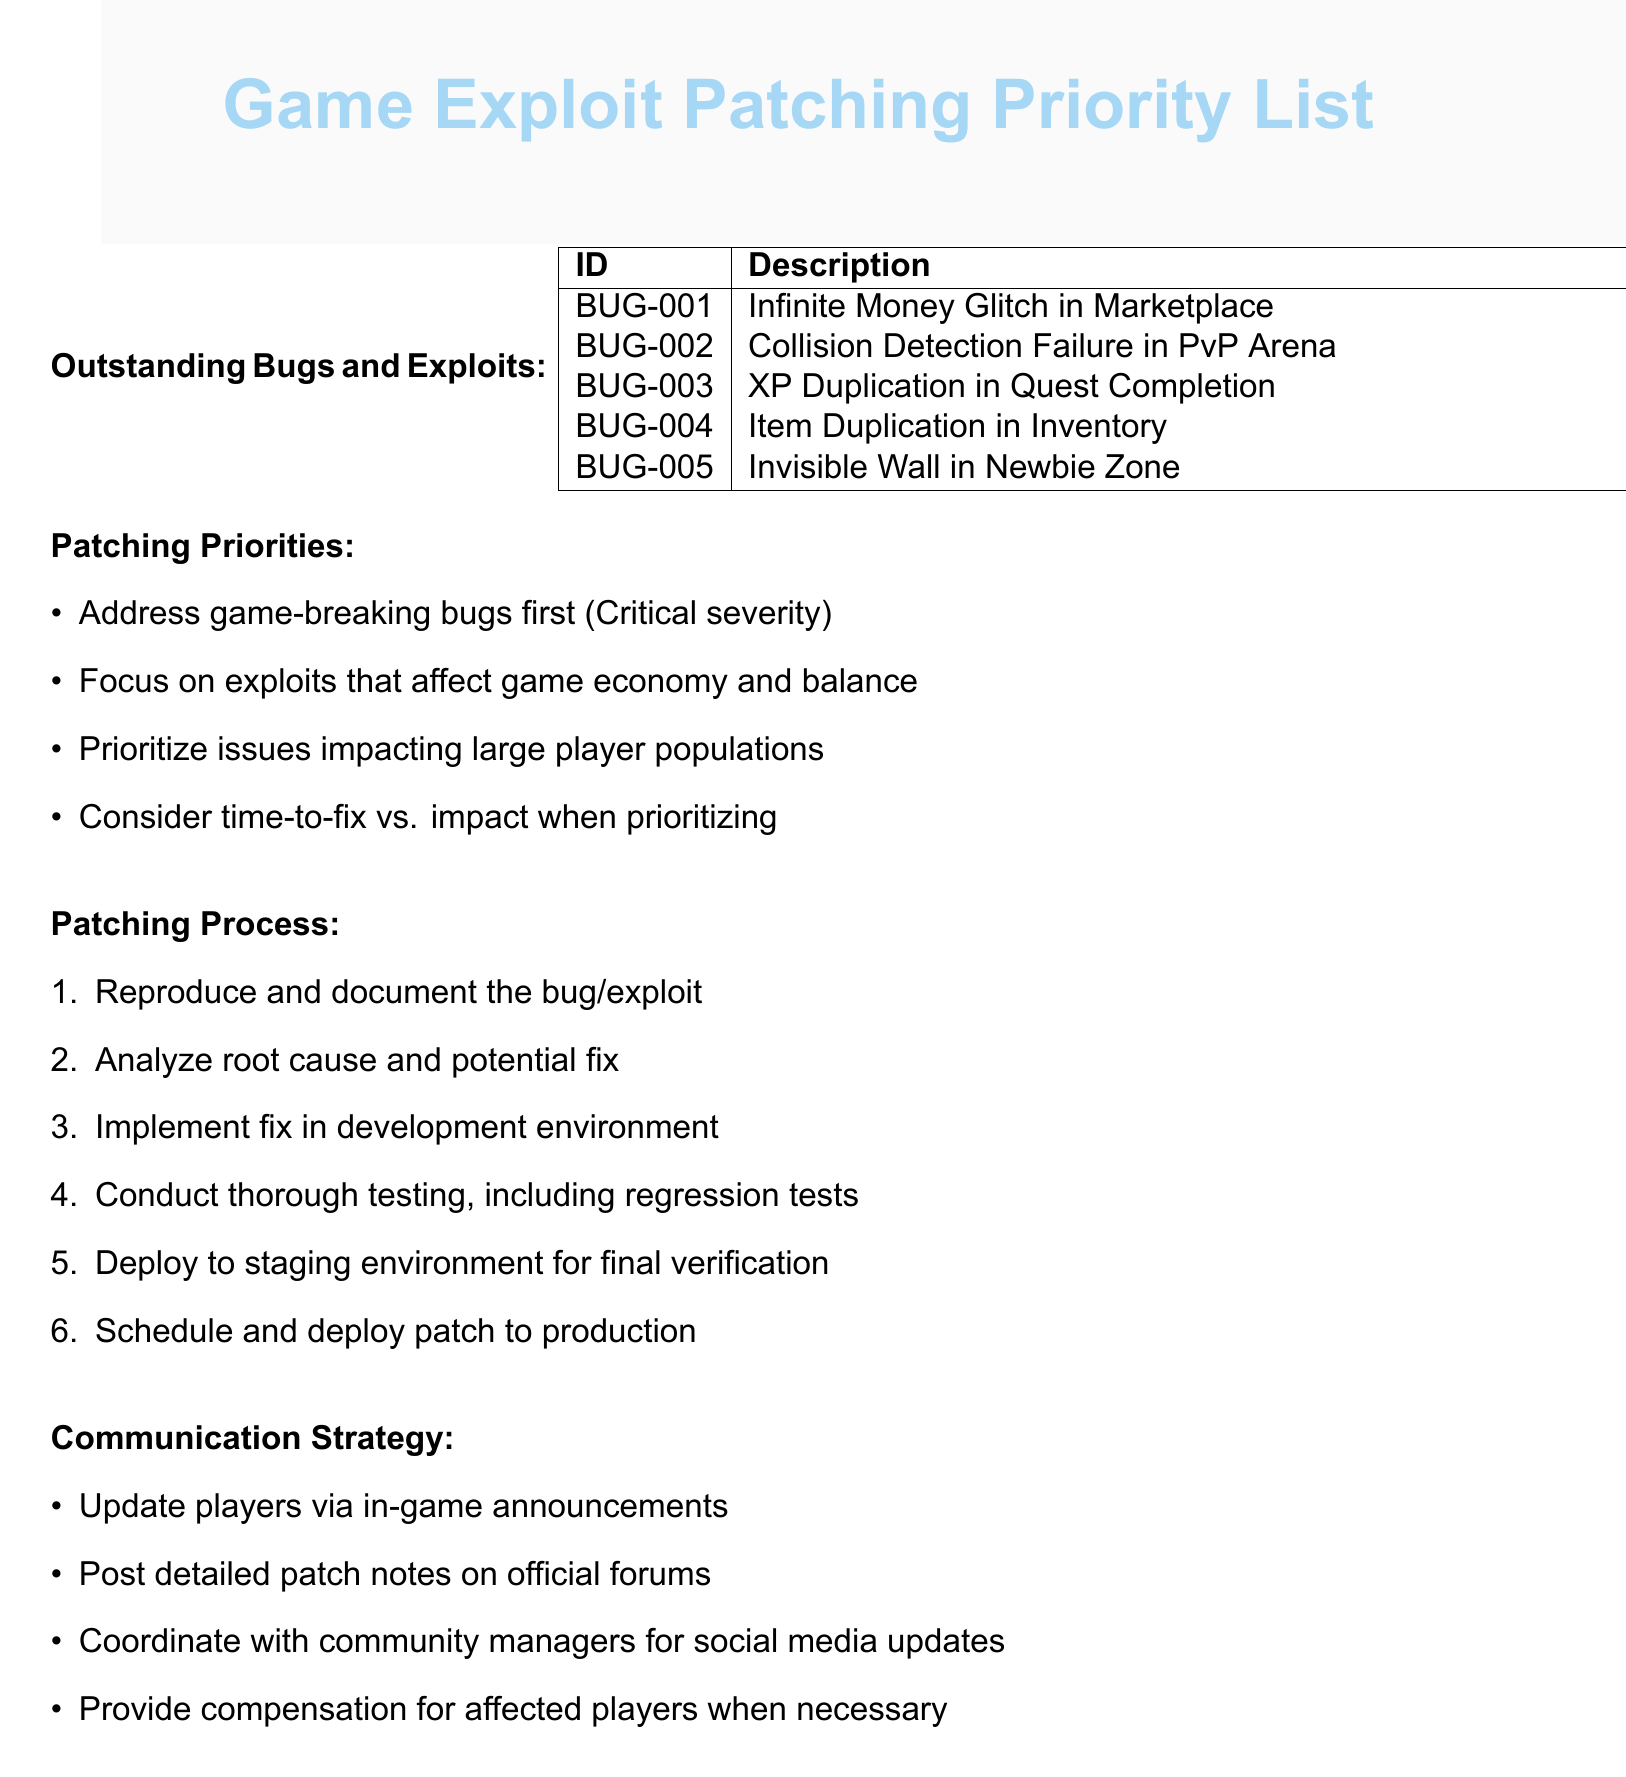What is the description of BUG-001? BUG-001 refers to the "Infinite Money Glitch in Marketplace," as listed in the document.
Answer: Infinite Money Glitch in Marketplace How many hours are estimated to fix the low severity bug? The low severity bug (BUG-005) is estimated to take 2 hours to patch, as shown in the document.
Answer: 2 hours What is the severity of the collision detection failure? The document states that the collision detection failure (BUG-002) has a high severity rating.
Answer: High Which bug has the highest severity rating? According to the document, the highest severity rating is for the "Infinite Money Glitch in Marketplace," which is critical.
Answer: Infinite Money Glitch in Marketplace What is the estimated time to patch the XP duplication bug? The document indicates that XP Duplication in Quest Completion (BUG-003) is estimated to take 1 day to patch.
Answer: 1 day What is the primary focus for patching priorities? The document emphasizes that the primary focus should be to address game-breaking bugs first, specifically those with critical severity.
Answer: Address game-breaking bugs first How many steps are listed in the patching process? The document outlines a total of six steps in the patching process as part of its structure.
Answer: 6 What is a suggested communication strategy for players? One communication strategy proposed is to update players via in-game announcements, as detailed in the document.
Answer: Update players via in-game announcements Which bug will take the longest to patch? The document indicates that the "Infinite Money Glitch in Marketplace" (BUG-001) will take the longest at 3 days to patch.
Answer: 3 days 